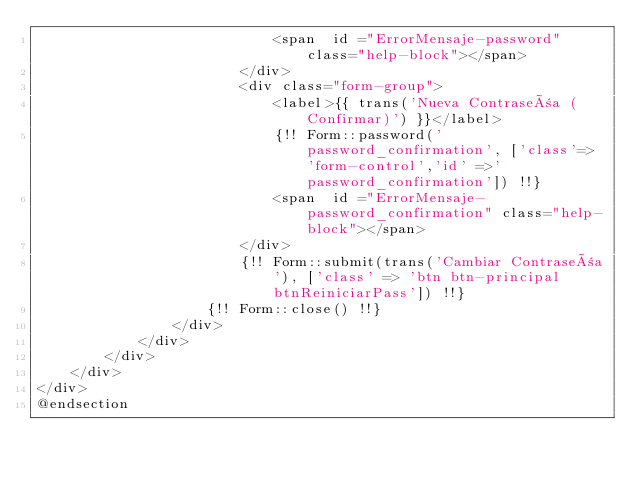Convert code to text. <code><loc_0><loc_0><loc_500><loc_500><_PHP_>                            <span  id ="ErrorMensaje-password" class="help-block"></span>
                        </div>
                        <div class="form-group">
                            <label>{{ trans('Nueva Contraseña (Confirmar)') }}</label>
                            {!! Form::password('password_confirmation', ['class'=> 'form-control','id' =>'password_confirmation']) !!}
                            <span  id ="ErrorMensaje-password_confirmation" class="help-block"></span>
                        </div>
                        {!! Form::submit(trans('Cambiar Contraseña'), ['class' => 'btn btn-principal btnReiniciarPass']) !!}
                    {!! Form::close() !!}
                </div>
            </div>
        </div>
    </div>
</div>
@endsection

</code> 